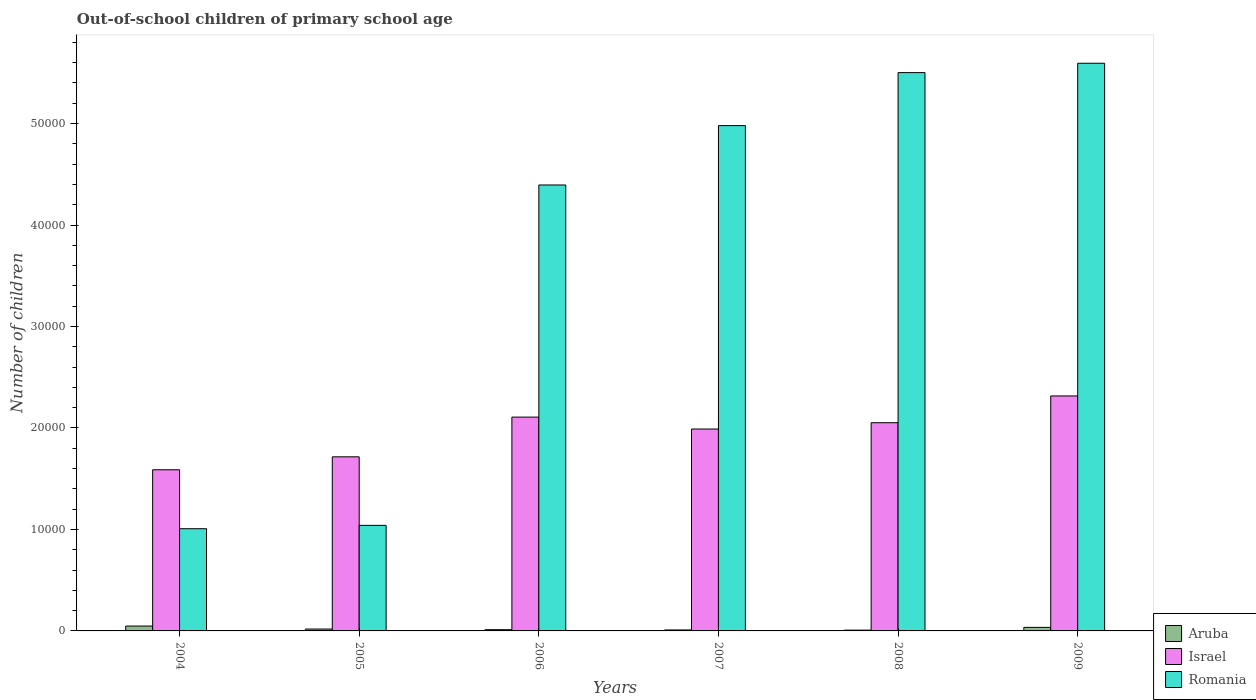How many bars are there on the 3rd tick from the right?
Ensure brevity in your answer.  3. What is the number of out-of-school children in Romania in 2004?
Give a very brief answer. 1.01e+04. Across all years, what is the maximum number of out-of-school children in Aruba?
Offer a very short reply. 480. In which year was the number of out-of-school children in Aruba maximum?
Your response must be concise. 2004. In which year was the number of out-of-school children in Romania minimum?
Offer a terse response. 2004. What is the total number of out-of-school children in Romania in the graph?
Your answer should be very brief. 2.25e+05. What is the difference between the number of out-of-school children in Israel in 2005 and that in 2006?
Offer a terse response. -3914. What is the difference between the number of out-of-school children in Aruba in 2005 and the number of out-of-school children in Israel in 2006?
Provide a succinct answer. -2.09e+04. What is the average number of out-of-school children in Romania per year?
Offer a terse response. 3.75e+04. In the year 2009, what is the difference between the number of out-of-school children in Israel and number of out-of-school children in Romania?
Make the answer very short. -3.28e+04. In how many years, is the number of out-of-school children in Israel greater than 6000?
Offer a terse response. 6. What is the ratio of the number of out-of-school children in Romania in 2005 to that in 2006?
Provide a short and direct response. 0.24. What is the difference between the highest and the second highest number of out-of-school children in Israel?
Make the answer very short. 2084. What is the difference between the highest and the lowest number of out-of-school children in Israel?
Keep it short and to the point. 7273. What does the 3rd bar from the left in 2008 represents?
Offer a very short reply. Romania. What does the 1st bar from the right in 2004 represents?
Your answer should be very brief. Romania. Are all the bars in the graph horizontal?
Your answer should be compact. No. How many years are there in the graph?
Provide a short and direct response. 6. What is the difference between two consecutive major ticks on the Y-axis?
Provide a short and direct response. 10000. What is the title of the graph?
Provide a succinct answer. Out-of-school children of primary school age. Does "Angola" appear as one of the legend labels in the graph?
Provide a short and direct response. No. What is the label or title of the X-axis?
Give a very brief answer. Years. What is the label or title of the Y-axis?
Your answer should be compact. Number of children. What is the Number of children of Aruba in 2004?
Give a very brief answer. 480. What is the Number of children in Israel in 2004?
Offer a terse response. 1.59e+04. What is the Number of children of Romania in 2004?
Provide a succinct answer. 1.01e+04. What is the Number of children in Aruba in 2005?
Keep it short and to the point. 186. What is the Number of children in Israel in 2005?
Make the answer very short. 1.72e+04. What is the Number of children of Romania in 2005?
Make the answer very short. 1.04e+04. What is the Number of children in Aruba in 2006?
Make the answer very short. 123. What is the Number of children of Israel in 2006?
Make the answer very short. 2.11e+04. What is the Number of children of Romania in 2006?
Provide a short and direct response. 4.39e+04. What is the Number of children in Aruba in 2007?
Keep it short and to the point. 96. What is the Number of children in Israel in 2007?
Offer a very short reply. 1.99e+04. What is the Number of children in Romania in 2007?
Provide a short and direct response. 4.98e+04. What is the Number of children in Israel in 2008?
Keep it short and to the point. 2.05e+04. What is the Number of children of Romania in 2008?
Provide a short and direct response. 5.50e+04. What is the Number of children in Aruba in 2009?
Ensure brevity in your answer.  350. What is the Number of children of Israel in 2009?
Your answer should be compact. 2.32e+04. What is the Number of children of Romania in 2009?
Offer a very short reply. 5.59e+04. Across all years, what is the maximum Number of children in Aruba?
Provide a succinct answer. 480. Across all years, what is the maximum Number of children of Israel?
Give a very brief answer. 2.32e+04. Across all years, what is the maximum Number of children in Romania?
Offer a terse response. 5.59e+04. Across all years, what is the minimum Number of children of Aruba?
Make the answer very short. 78. Across all years, what is the minimum Number of children of Israel?
Give a very brief answer. 1.59e+04. Across all years, what is the minimum Number of children in Romania?
Provide a short and direct response. 1.01e+04. What is the total Number of children in Aruba in the graph?
Give a very brief answer. 1313. What is the total Number of children in Israel in the graph?
Keep it short and to the point. 1.18e+05. What is the total Number of children in Romania in the graph?
Your answer should be compact. 2.25e+05. What is the difference between the Number of children in Aruba in 2004 and that in 2005?
Your answer should be compact. 294. What is the difference between the Number of children of Israel in 2004 and that in 2005?
Offer a terse response. -1275. What is the difference between the Number of children in Romania in 2004 and that in 2005?
Make the answer very short. -330. What is the difference between the Number of children in Aruba in 2004 and that in 2006?
Offer a terse response. 357. What is the difference between the Number of children in Israel in 2004 and that in 2006?
Make the answer very short. -5189. What is the difference between the Number of children in Romania in 2004 and that in 2006?
Your response must be concise. -3.39e+04. What is the difference between the Number of children of Aruba in 2004 and that in 2007?
Keep it short and to the point. 384. What is the difference between the Number of children of Israel in 2004 and that in 2007?
Your answer should be compact. -4014. What is the difference between the Number of children in Romania in 2004 and that in 2007?
Offer a very short reply. -3.97e+04. What is the difference between the Number of children in Aruba in 2004 and that in 2008?
Your answer should be very brief. 402. What is the difference between the Number of children in Israel in 2004 and that in 2008?
Your answer should be compact. -4635. What is the difference between the Number of children of Romania in 2004 and that in 2008?
Offer a very short reply. -4.49e+04. What is the difference between the Number of children of Aruba in 2004 and that in 2009?
Your answer should be very brief. 130. What is the difference between the Number of children of Israel in 2004 and that in 2009?
Offer a terse response. -7273. What is the difference between the Number of children of Romania in 2004 and that in 2009?
Provide a short and direct response. -4.59e+04. What is the difference between the Number of children in Aruba in 2005 and that in 2006?
Offer a very short reply. 63. What is the difference between the Number of children in Israel in 2005 and that in 2006?
Provide a succinct answer. -3914. What is the difference between the Number of children in Romania in 2005 and that in 2006?
Offer a terse response. -3.35e+04. What is the difference between the Number of children in Israel in 2005 and that in 2007?
Your response must be concise. -2739. What is the difference between the Number of children in Romania in 2005 and that in 2007?
Keep it short and to the point. -3.94e+04. What is the difference between the Number of children of Aruba in 2005 and that in 2008?
Ensure brevity in your answer.  108. What is the difference between the Number of children of Israel in 2005 and that in 2008?
Make the answer very short. -3360. What is the difference between the Number of children in Romania in 2005 and that in 2008?
Ensure brevity in your answer.  -4.46e+04. What is the difference between the Number of children of Aruba in 2005 and that in 2009?
Ensure brevity in your answer.  -164. What is the difference between the Number of children of Israel in 2005 and that in 2009?
Make the answer very short. -5998. What is the difference between the Number of children in Romania in 2005 and that in 2009?
Provide a succinct answer. -4.55e+04. What is the difference between the Number of children of Aruba in 2006 and that in 2007?
Provide a succinct answer. 27. What is the difference between the Number of children in Israel in 2006 and that in 2007?
Your answer should be compact. 1175. What is the difference between the Number of children of Romania in 2006 and that in 2007?
Provide a succinct answer. -5850. What is the difference between the Number of children of Aruba in 2006 and that in 2008?
Your answer should be very brief. 45. What is the difference between the Number of children of Israel in 2006 and that in 2008?
Make the answer very short. 554. What is the difference between the Number of children of Romania in 2006 and that in 2008?
Your answer should be compact. -1.11e+04. What is the difference between the Number of children of Aruba in 2006 and that in 2009?
Your answer should be compact. -227. What is the difference between the Number of children of Israel in 2006 and that in 2009?
Give a very brief answer. -2084. What is the difference between the Number of children in Romania in 2006 and that in 2009?
Ensure brevity in your answer.  -1.20e+04. What is the difference between the Number of children of Israel in 2007 and that in 2008?
Keep it short and to the point. -621. What is the difference between the Number of children of Romania in 2007 and that in 2008?
Your answer should be very brief. -5223. What is the difference between the Number of children in Aruba in 2007 and that in 2009?
Your answer should be very brief. -254. What is the difference between the Number of children in Israel in 2007 and that in 2009?
Offer a very short reply. -3259. What is the difference between the Number of children in Romania in 2007 and that in 2009?
Provide a short and direct response. -6145. What is the difference between the Number of children in Aruba in 2008 and that in 2009?
Give a very brief answer. -272. What is the difference between the Number of children in Israel in 2008 and that in 2009?
Your response must be concise. -2638. What is the difference between the Number of children of Romania in 2008 and that in 2009?
Provide a short and direct response. -922. What is the difference between the Number of children in Aruba in 2004 and the Number of children in Israel in 2005?
Offer a terse response. -1.67e+04. What is the difference between the Number of children of Aruba in 2004 and the Number of children of Romania in 2005?
Your answer should be very brief. -9923. What is the difference between the Number of children of Israel in 2004 and the Number of children of Romania in 2005?
Ensure brevity in your answer.  5480. What is the difference between the Number of children in Aruba in 2004 and the Number of children in Israel in 2006?
Offer a terse response. -2.06e+04. What is the difference between the Number of children in Aruba in 2004 and the Number of children in Romania in 2006?
Your answer should be compact. -4.35e+04. What is the difference between the Number of children of Israel in 2004 and the Number of children of Romania in 2006?
Provide a short and direct response. -2.81e+04. What is the difference between the Number of children in Aruba in 2004 and the Number of children in Israel in 2007?
Give a very brief answer. -1.94e+04. What is the difference between the Number of children of Aruba in 2004 and the Number of children of Romania in 2007?
Give a very brief answer. -4.93e+04. What is the difference between the Number of children in Israel in 2004 and the Number of children in Romania in 2007?
Offer a terse response. -3.39e+04. What is the difference between the Number of children of Aruba in 2004 and the Number of children of Israel in 2008?
Provide a short and direct response. -2.00e+04. What is the difference between the Number of children of Aruba in 2004 and the Number of children of Romania in 2008?
Your response must be concise. -5.45e+04. What is the difference between the Number of children in Israel in 2004 and the Number of children in Romania in 2008?
Offer a terse response. -3.91e+04. What is the difference between the Number of children in Aruba in 2004 and the Number of children in Israel in 2009?
Keep it short and to the point. -2.27e+04. What is the difference between the Number of children of Aruba in 2004 and the Number of children of Romania in 2009?
Make the answer very short. -5.55e+04. What is the difference between the Number of children of Israel in 2004 and the Number of children of Romania in 2009?
Your answer should be compact. -4.01e+04. What is the difference between the Number of children in Aruba in 2005 and the Number of children in Israel in 2006?
Make the answer very short. -2.09e+04. What is the difference between the Number of children in Aruba in 2005 and the Number of children in Romania in 2006?
Your answer should be very brief. -4.38e+04. What is the difference between the Number of children of Israel in 2005 and the Number of children of Romania in 2006?
Offer a terse response. -2.68e+04. What is the difference between the Number of children in Aruba in 2005 and the Number of children in Israel in 2007?
Provide a short and direct response. -1.97e+04. What is the difference between the Number of children in Aruba in 2005 and the Number of children in Romania in 2007?
Provide a succinct answer. -4.96e+04. What is the difference between the Number of children in Israel in 2005 and the Number of children in Romania in 2007?
Keep it short and to the point. -3.26e+04. What is the difference between the Number of children of Aruba in 2005 and the Number of children of Israel in 2008?
Your answer should be very brief. -2.03e+04. What is the difference between the Number of children of Aruba in 2005 and the Number of children of Romania in 2008?
Your answer should be compact. -5.48e+04. What is the difference between the Number of children of Israel in 2005 and the Number of children of Romania in 2008?
Provide a short and direct response. -3.79e+04. What is the difference between the Number of children in Aruba in 2005 and the Number of children in Israel in 2009?
Provide a short and direct response. -2.30e+04. What is the difference between the Number of children in Aruba in 2005 and the Number of children in Romania in 2009?
Keep it short and to the point. -5.58e+04. What is the difference between the Number of children in Israel in 2005 and the Number of children in Romania in 2009?
Provide a succinct answer. -3.88e+04. What is the difference between the Number of children in Aruba in 2006 and the Number of children in Israel in 2007?
Your answer should be compact. -1.98e+04. What is the difference between the Number of children of Aruba in 2006 and the Number of children of Romania in 2007?
Your answer should be very brief. -4.97e+04. What is the difference between the Number of children of Israel in 2006 and the Number of children of Romania in 2007?
Your answer should be very brief. -2.87e+04. What is the difference between the Number of children in Aruba in 2006 and the Number of children in Israel in 2008?
Provide a short and direct response. -2.04e+04. What is the difference between the Number of children in Aruba in 2006 and the Number of children in Romania in 2008?
Make the answer very short. -5.49e+04. What is the difference between the Number of children in Israel in 2006 and the Number of children in Romania in 2008?
Provide a succinct answer. -3.39e+04. What is the difference between the Number of children in Aruba in 2006 and the Number of children in Israel in 2009?
Provide a succinct answer. -2.30e+04. What is the difference between the Number of children of Aruba in 2006 and the Number of children of Romania in 2009?
Your answer should be very brief. -5.58e+04. What is the difference between the Number of children in Israel in 2006 and the Number of children in Romania in 2009?
Offer a terse response. -3.49e+04. What is the difference between the Number of children in Aruba in 2007 and the Number of children in Israel in 2008?
Offer a very short reply. -2.04e+04. What is the difference between the Number of children of Aruba in 2007 and the Number of children of Romania in 2008?
Keep it short and to the point. -5.49e+04. What is the difference between the Number of children in Israel in 2007 and the Number of children in Romania in 2008?
Ensure brevity in your answer.  -3.51e+04. What is the difference between the Number of children in Aruba in 2007 and the Number of children in Israel in 2009?
Keep it short and to the point. -2.31e+04. What is the difference between the Number of children in Aruba in 2007 and the Number of children in Romania in 2009?
Give a very brief answer. -5.58e+04. What is the difference between the Number of children of Israel in 2007 and the Number of children of Romania in 2009?
Your answer should be compact. -3.60e+04. What is the difference between the Number of children in Aruba in 2008 and the Number of children in Israel in 2009?
Give a very brief answer. -2.31e+04. What is the difference between the Number of children of Aruba in 2008 and the Number of children of Romania in 2009?
Ensure brevity in your answer.  -5.59e+04. What is the difference between the Number of children of Israel in 2008 and the Number of children of Romania in 2009?
Provide a short and direct response. -3.54e+04. What is the average Number of children in Aruba per year?
Your answer should be compact. 218.83. What is the average Number of children of Israel per year?
Your answer should be compact. 1.96e+04. What is the average Number of children of Romania per year?
Provide a succinct answer. 3.75e+04. In the year 2004, what is the difference between the Number of children in Aruba and Number of children in Israel?
Provide a short and direct response. -1.54e+04. In the year 2004, what is the difference between the Number of children in Aruba and Number of children in Romania?
Offer a terse response. -9593. In the year 2004, what is the difference between the Number of children of Israel and Number of children of Romania?
Keep it short and to the point. 5810. In the year 2005, what is the difference between the Number of children of Aruba and Number of children of Israel?
Your answer should be compact. -1.70e+04. In the year 2005, what is the difference between the Number of children in Aruba and Number of children in Romania?
Ensure brevity in your answer.  -1.02e+04. In the year 2005, what is the difference between the Number of children of Israel and Number of children of Romania?
Your answer should be very brief. 6755. In the year 2006, what is the difference between the Number of children in Aruba and Number of children in Israel?
Your answer should be very brief. -2.09e+04. In the year 2006, what is the difference between the Number of children of Aruba and Number of children of Romania?
Provide a succinct answer. -4.38e+04. In the year 2006, what is the difference between the Number of children of Israel and Number of children of Romania?
Offer a terse response. -2.29e+04. In the year 2007, what is the difference between the Number of children in Aruba and Number of children in Israel?
Give a very brief answer. -1.98e+04. In the year 2007, what is the difference between the Number of children in Aruba and Number of children in Romania?
Make the answer very short. -4.97e+04. In the year 2007, what is the difference between the Number of children in Israel and Number of children in Romania?
Keep it short and to the point. -2.99e+04. In the year 2008, what is the difference between the Number of children of Aruba and Number of children of Israel?
Provide a short and direct response. -2.04e+04. In the year 2008, what is the difference between the Number of children of Aruba and Number of children of Romania?
Offer a very short reply. -5.49e+04. In the year 2008, what is the difference between the Number of children of Israel and Number of children of Romania?
Provide a short and direct response. -3.45e+04. In the year 2009, what is the difference between the Number of children in Aruba and Number of children in Israel?
Make the answer very short. -2.28e+04. In the year 2009, what is the difference between the Number of children of Aruba and Number of children of Romania?
Give a very brief answer. -5.56e+04. In the year 2009, what is the difference between the Number of children of Israel and Number of children of Romania?
Keep it short and to the point. -3.28e+04. What is the ratio of the Number of children of Aruba in 2004 to that in 2005?
Offer a terse response. 2.58. What is the ratio of the Number of children in Israel in 2004 to that in 2005?
Ensure brevity in your answer.  0.93. What is the ratio of the Number of children in Romania in 2004 to that in 2005?
Provide a succinct answer. 0.97. What is the ratio of the Number of children in Aruba in 2004 to that in 2006?
Provide a succinct answer. 3.9. What is the ratio of the Number of children in Israel in 2004 to that in 2006?
Your answer should be compact. 0.75. What is the ratio of the Number of children of Romania in 2004 to that in 2006?
Offer a very short reply. 0.23. What is the ratio of the Number of children in Aruba in 2004 to that in 2007?
Make the answer very short. 5. What is the ratio of the Number of children of Israel in 2004 to that in 2007?
Provide a succinct answer. 0.8. What is the ratio of the Number of children in Romania in 2004 to that in 2007?
Provide a short and direct response. 0.2. What is the ratio of the Number of children in Aruba in 2004 to that in 2008?
Your answer should be compact. 6.15. What is the ratio of the Number of children in Israel in 2004 to that in 2008?
Offer a very short reply. 0.77. What is the ratio of the Number of children in Romania in 2004 to that in 2008?
Ensure brevity in your answer.  0.18. What is the ratio of the Number of children in Aruba in 2004 to that in 2009?
Make the answer very short. 1.37. What is the ratio of the Number of children of Israel in 2004 to that in 2009?
Give a very brief answer. 0.69. What is the ratio of the Number of children in Romania in 2004 to that in 2009?
Your answer should be compact. 0.18. What is the ratio of the Number of children in Aruba in 2005 to that in 2006?
Offer a very short reply. 1.51. What is the ratio of the Number of children of Israel in 2005 to that in 2006?
Your response must be concise. 0.81. What is the ratio of the Number of children in Romania in 2005 to that in 2006?
Keep it short and to the point. 0.24. What is the ratio of the Number of children in Aruba in 2005 to that in 2007?
Offer a terse response. 1.94. What is the ratio of the Number of children of Israel in 2005 to that in 2007?
Offer a terse response. 0.86. What is the ratio of the Number of children of Romania in 2005 to that in 2007?
Make the answer very short. 0.21. What is the ratio of the Number of children of Aruba in 2005 to that in 2008?
Keep it short and to the point. 2.38. What is the ratio of the Number of children of Israel in 2005 to that in 2008?
Provide a short and direct response. 0.84. What is the ratio of the Number of children in Romania in 2005 to that in 2008?
Offer a terse response. 0.19. What is the ratio of the Number of children in Aruba in 2005 to that in 2009?
Keep it short and to the point. 0.53. What is the ratio of the Number of children in Israel in 2005 to that in 2009?
Offer a very short reply. 0.74. What is the ratio of the Number of children of Romania in 2005 to that in 2009?
Give a very brief answer. 0.19. What is the ratio of the Number of children in Aruba in 2006 to that in 2007?
Your response must be concise. 1.28. What is the ratio of the Number of children of Israel in 2006 to that in 2007?
Offer a terse response. 1.06. What is the ratio of the Number of children of Romania in 2006 to that in 2007?
Offer a very short reply. 0.88. What is the ratio of the Number of children of Aruba in 2006 to that in 2008?
Offer a very short reply. 1.58. What is the ratio of the Number of children in Romania in 2006 to that in 2008?
Your answer should be compact. 0.8. What is the ratio of the Number of children of Aruba in 2006 to that in 2009?
Your answer should be very brief. 0.35. What is the ratio of the Number of children in Israel in 2006 to that in 2009?
Ensure brevity in your answer.  0.91. What is the ratio of the Number of children in Romania in 2006 to that in 2009?
Your answer should be very brief. 0.79. What is the ratio of the Number of children in Aruba in 2007 to that in 2008?
Offer a very short reply. 1.23. What is the ratio of the Number of children in Israel in 2007 to that in 2008?
Provide a succinct answer. 0.97. What is the ratio of the Number of children in Romania in 2007 to that in 2008?
Keep it short and to the point. 0.91. What is the ratio of the Number of children in Aruba in 2007 to that in 2009?
Ensure brevity in your answer.  0.27. What is the ratio of the Number of children in Israel in 2007 to that in 2009?
Provide a short and direct response. 0.86. What is the ratio of the Number of children of Romania in 2007 to that in 2009?
Ensure brevity in your answer.  0.89. What is the ratio of the Number of children in Aruba in 2008 to that in 2009?
Provide a short and direct response. 0.22. What is the ratio of the Number of children of Israel in 2008 to that in 2009?
Offer a terse response. 0.89. What is the ratio of the Number of children in Romania in 2008 to that in 2009?
Keep it short and to the point. 0.98. What is the difference between the highest and the second highest Number of children of Aruba?
Your answer should be very brief. 130. What is the difference between the highest and the second highest Number of children in Israel?
Offer a terse response. 2084. What is the difference between the highest and the second highest Number of children of Romania?
Give a very brief answer. 922. What is the difference between the highest and the lowest Number of children in Aruba?
Your answer should be very brief. 402. What is the difference between the highest and the lowest Number of children of Israel?
Your response must be concise. 7273. What is the difference between the highest and the lowest Number of children in Romania?
Give a very brief answer. 4.59e+04. 